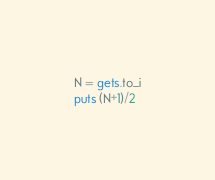Convert code to text. <code><loc_0><loc_0><loc_500><loc_500><_Ruby_>N = gets.to_i
puts (N+1)/2</code> 